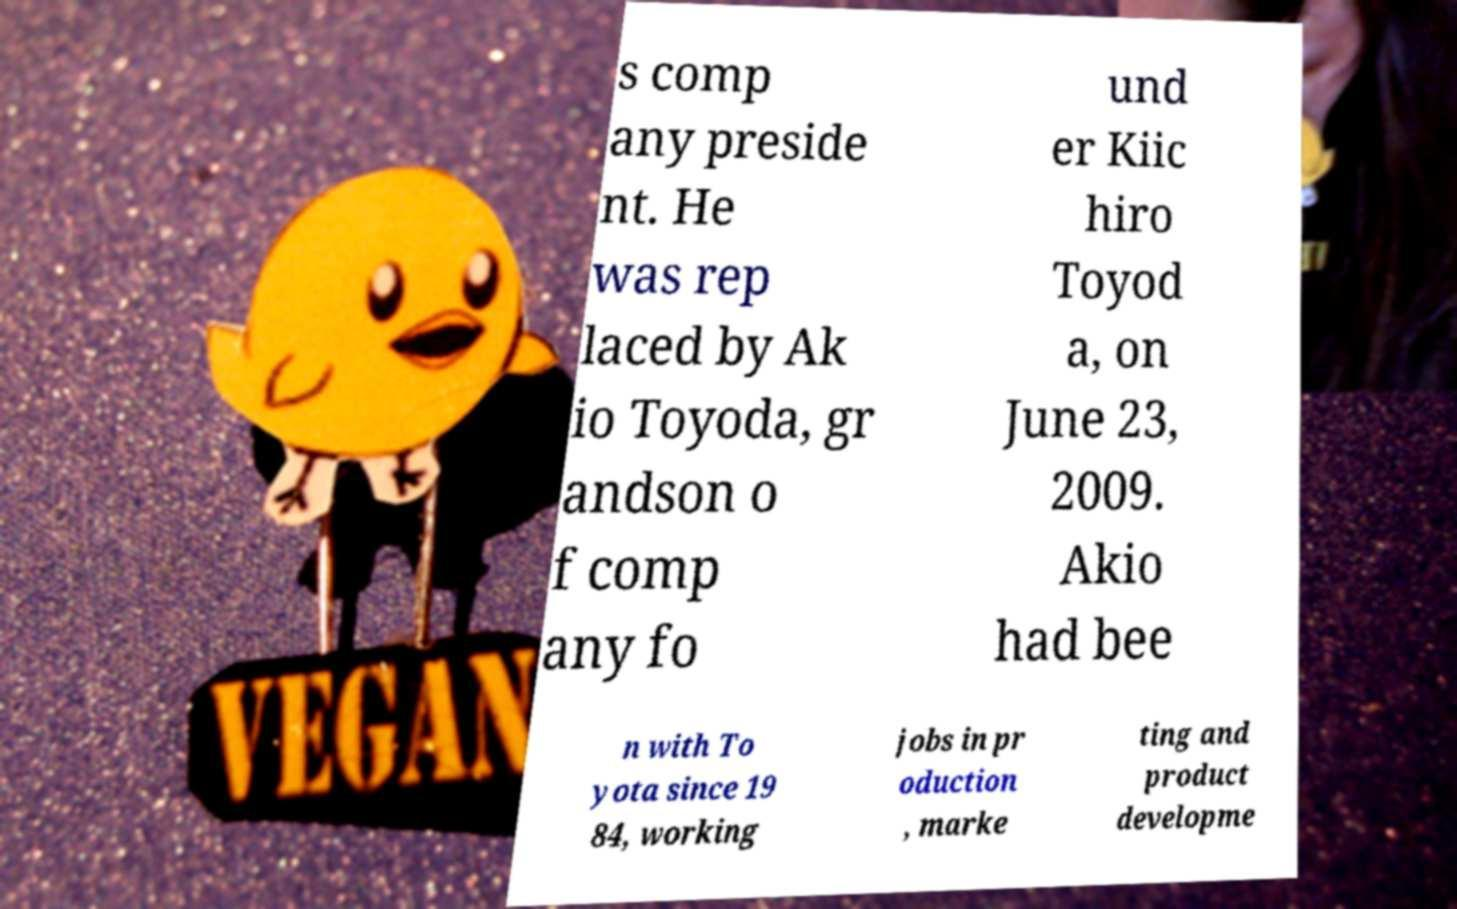For documentation purposes, I need the text within this image transcribed. Could you provide that? s comp any preside nt. He was rep laced by Ak io Toyoda, gr andson o f comp any fo und er Kiic hiro Toyod a, on June 23, 2009. Akio had bee n with To yota since 19 84, working jobs in pr oduction , marke ting and product developme 